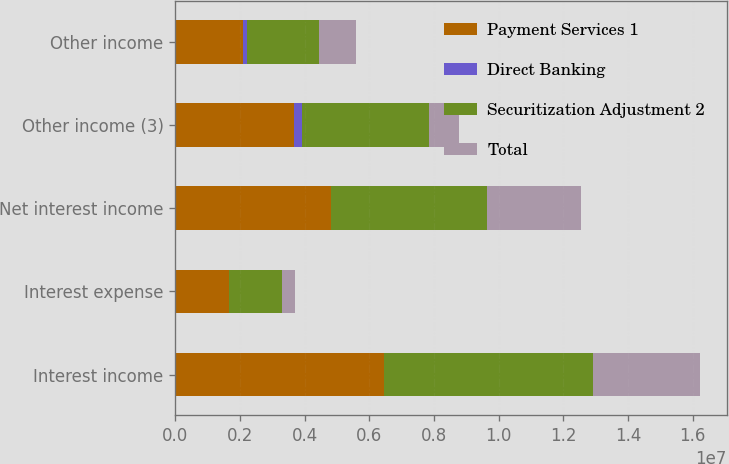Convert chart to OTSL. <chart><loc_0><loc_0><loc_500><loc_500><stacked_bar_chart><ecel><fcel>Interest income<fcel>Interest expense<fcel>Net interest income<fcel>Other income (3)<fcel>Other income<nl><fcel>Payment Services 1<fcel>6.45997e+06<fcel>1.6482e+06<fcel>4.81178e+06<fcel>3.67788e+06<fcel>2.10108e+06<nl><fcel>Direct Banking<fcel>1098<fcel>222<fcel>876<fcel>239794<fcel>118700<nl><fcel>Securitization Adjustment 2<fcel>6.46107e+06<fcel>1.64842e+06<fcel>4.81265e+06<fcel>3.91768e+06<fcel>2.21978e+06<nl><fcel>Total<fcel>3.31599e+06<fcel>397136<fcel>2.91886e+06<fcel>922920<fcel>1.15691e+06<nl></chart> 